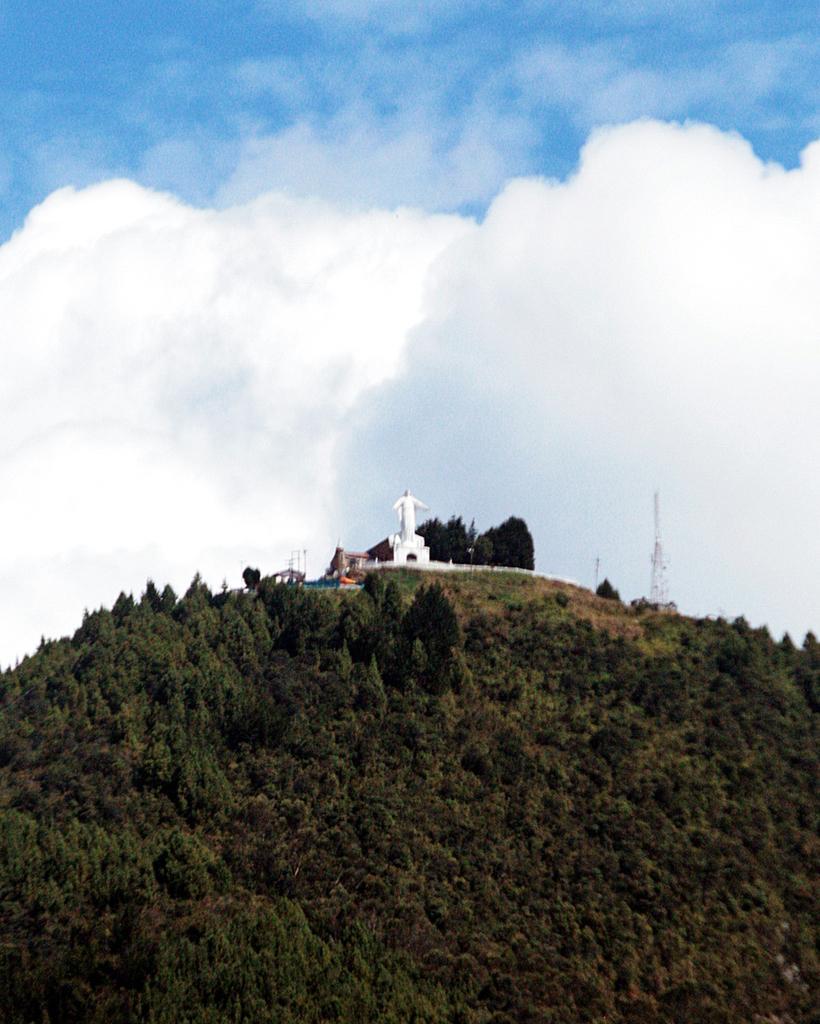Could you give a brief overview of what you see in this image? In this picture at the top we have blue sky & in the middle we have a statue and at the bottom we have greenery and trees 